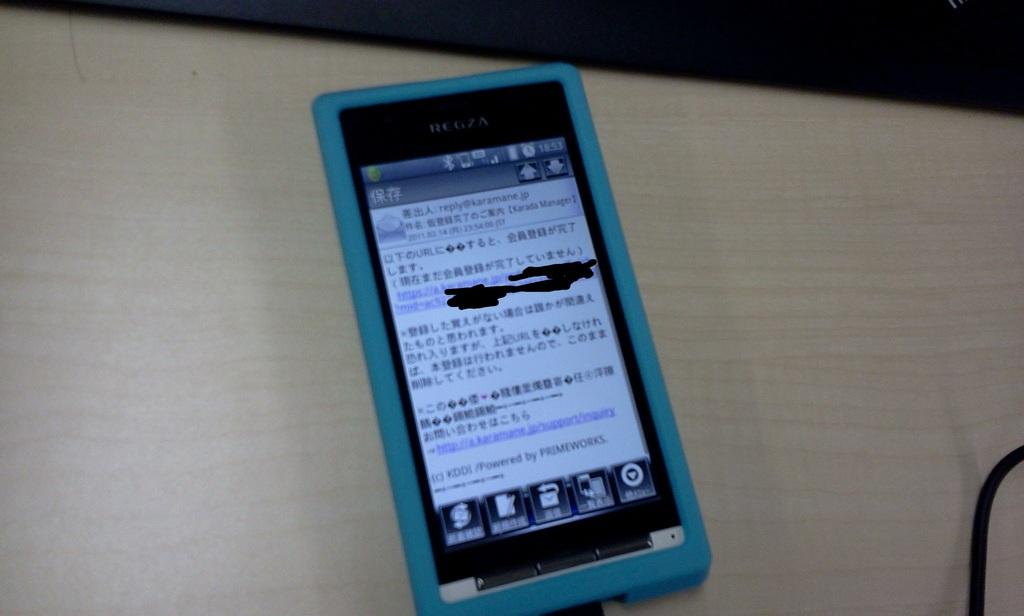What language is that?
Your answer should be very brief. Unanswerable. 